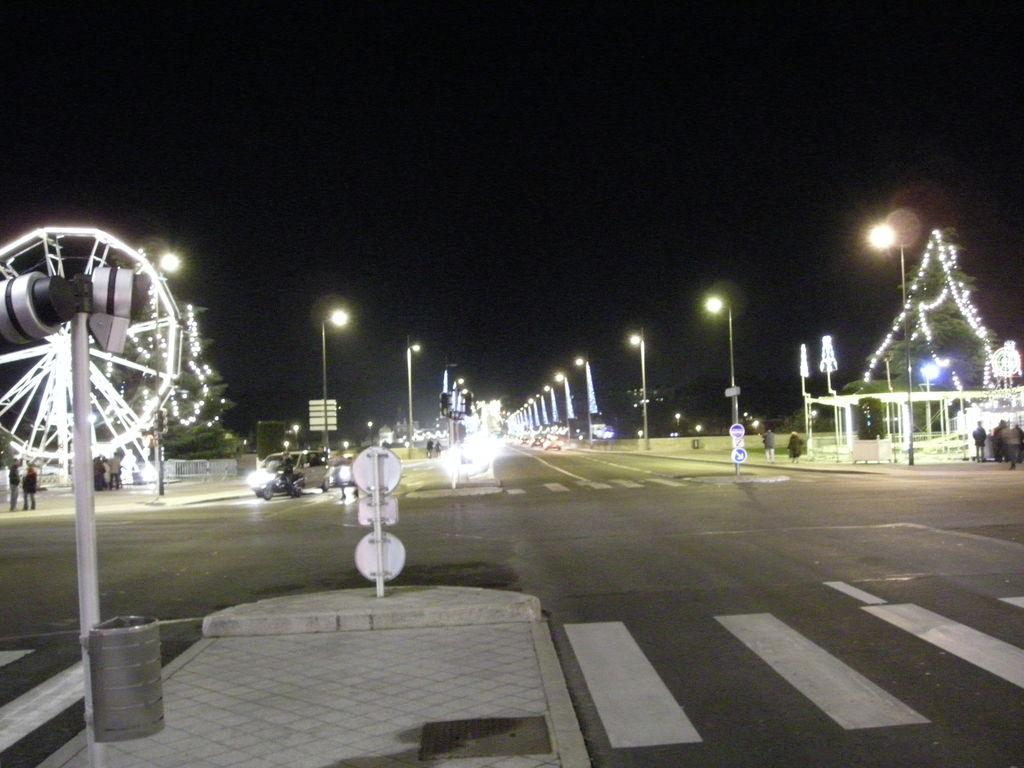What type of road is depicted in the image? There is a 4-way road in the image. What can be seen on the road? Vehicles are present on the road. What is located along the footpath and sideways? There are lights and sign boards on the footpath and sideways. Are there any spiders crawling on the sign boards in the image? There is no indication of spiders or any other animals in the image; it primarily features a 4-way road, vehicles, lights, and sign boards. 